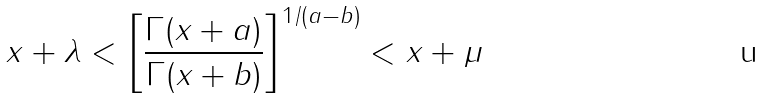<formula> <loc_0><loc_0><loc_500><loc_500>x + \lambda < \left [ \frac { \Gamma ( x + a ) } { \Gamma ( x + b ) } \right ] ^ { 1 / ( a - b ) } < x + \mu</formula> 